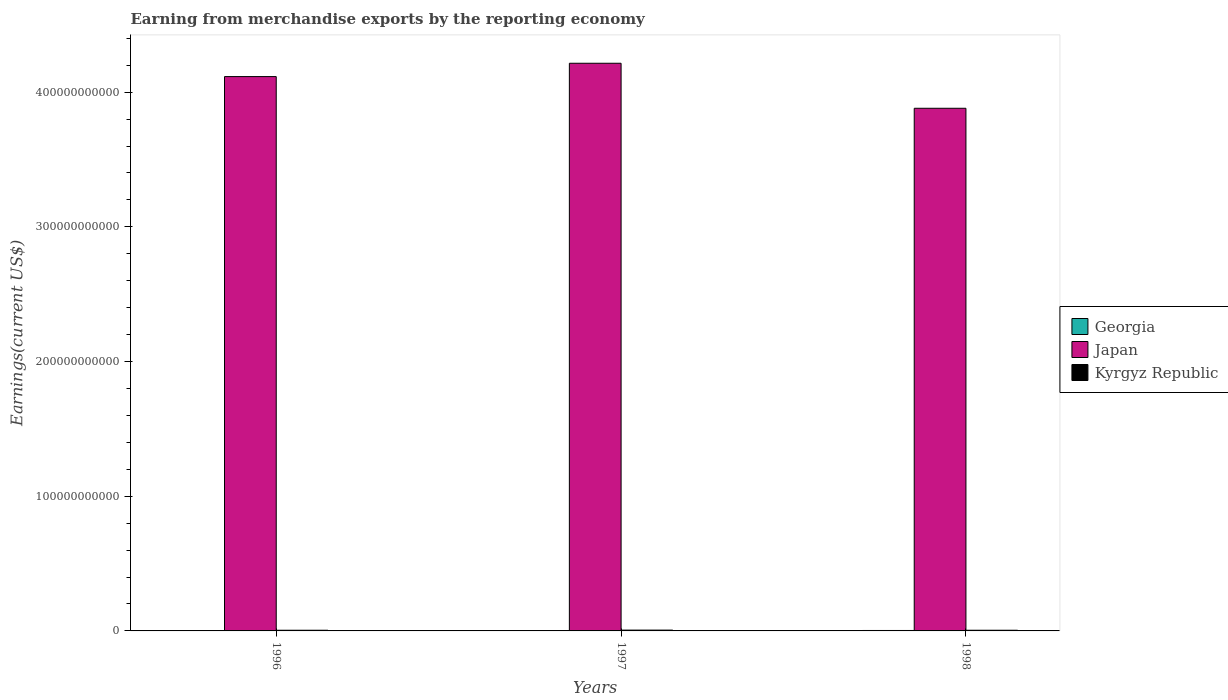Are the number of bars per tick equal to the number of legend labels?
Keep it short and to the point. Yes. Are the number of bars on each tick of the X-axis equal?
Keep it short and to the point. Yes. How many bars are there on the 3rd tick from the right?
Your answer should be very brief. 3. What is the amount earned from merchandise exports in Japan in 1998?
Provide a short and direct response. 3.88e+11. Across all years, what is the maximum amount earned from merchandise exports in Georgia?
Make the answer very short. 3.31e+08. Across all years, what is the minimum amount earned from merchandise exports in Japan?
Give a very brief answer. 3.88e+11. In which year was the amount earned from merchandise exports in Kyrgyz Republic maximum?
Your answer should be compact. 1997. In which year was the amount earned from merchandise exports in Georgia minimum?
Provide a short and direct response. 1996. What is the total amount earned from merchandise exports in Japan in the graph?
Your response must be concise. 1.22e+12. What is the difference between the amount earned from merchandise exports in Kyrgyz Republic in 1997 and that in 1998?
Keep it short and to the point. 1.01e+08. What is the difference between the amount earned from merchandise exports in Kyrgyz Republic in 1998 and the amount earned from merchandise exports in Japan in 1997?
Your answer should be compact. -4.21e+11. What is the average amount earned from merchandise exports in Kyrgyz Republic per year?
Ensure brevity in your answer.  5.41e+08. In the year 1998, what is the difference between the amount earned from merchandise exports in Georgia and amount earned from merchandise exports in Kyrgyz Republic?
Make the answer very short. -1.78e+08. In how many years, is the amount earned from merchandise exports in Georgia greater than 140000000000 US$?
Offer a terse response. 0. What is the ratio of the amount earned from merchandise exports in Japan in 1996 to that in 1997?
Your answer should be very brief. 0.98. Is the difference between the amount earned from merchandise exports in Georgia in 1997 and 1998 greater than the difference between the amount earned from merchandise exports in Kyrgyz Republic in 1997 and 1998?
Make the answer very short. No. What is the difference between the highest and the second highest amount earned from merchandise exports in Georgia?
Make the answer very short. 1.01e+08. What is the difference between the highest and the lowest amount earned from merchandise exports in Kyrgyz Republic?
Your answer should be compact. 1.04e+08. Is the sum of the amount earned from merchandise exports in Japan in 1997 and 1998 greater than the maximum amount earned from merchandise exports in Kyrgyz Republic across all years?
Offer a very short reply. Yes. What does the 3rd bar from the left in 1997 represents?
Offer a terse response. Kyrgyz Republic. Is it the case that in every year, the sum of the amount earned from merchandise exports in Japan and amount earned from merchandise exports in Georgia is greater than the amount earned from merchandise exports in Kyrgyz Republic?
Your answer should be very brief. Yes. What is the difference between two consecutive major ticks on the Y-axis?
Your answer should be very brief. 1.00e+11. Where does the legend appear in the graph?
Give a very brief answer. Center right. How many legend labels are there?
Your answer should be compact. 3. What is the title of the graph?
Your answer should be very brief. Earning from merchandise exports by the reporting economy. What is the label or title of the X-axis?
Your answer should be very brief. Years. What is the label or title of the Y-axis?
Provide a short and direct response. Earnings(current US$). What is the Earnings(current US$) of Georgia in 1996?
Make the answer very short. 1.99e+08. What is the Earnings(current US$) of Japan in 1996?
Your response must be concise. 4.12e+11. What is the Earnings(current US$) of Kyrgyz Republic in 1996?
Give a very brief answer. 5.06e+08. What is the Earnings(current US$) of Georgia in 1997?
Provide a short and direct response. 2.30e+08. What is the Earnings(current US$) in Japan in 1997?
Provide a succinct answer. 4.21e+11. What is the Earnings(current US$) in Kyrgyz Republic in 1997?
Provide a short and direct response. 6.09e+08. What is the Earnings(current US$) in Georgia in 1998?
Offer a very short reply. 3.31e+08. What is the Earnings(current US$) of Japan in 1998?
Offer a very short reply. 3.88e+11. What is the Earnings(current US$) in Kyrgyz Republic in 1998?
Provide a short and direct response. 5.09e+08. Across all years, what is the maximum Earnings(current US$) in Georgia?
Provide a short and direct response. 3.31e+08. Across all years, what is the maximum Earnings(current US$) in Japan?
Ensure brevity in your answer.  4.21e+11. Across all years, what is the maximum Earnings(current US$) of Kyrgyz Republic?
Your answer should be compact. 6.09e+08. Across all years, what is the minimum Earnings(current US$) in Georgia?
Your response must be concise. 1.99e+08. Across all years, what is the minimum Earnings(current US$) in Japan?
Your response must be concise. 3.88e+11. Across all years, what is the minimum Earnings(current US$) of Kyrgyz Republic?
Keep it short and to the point. 5.06e+08. What is the total Earnings(current US$) of Georgia in the graph?
Keep it short and to the point. 7.60e+08. What is the total Earnings(current US$) of Japan in the graph?
Give a very brief answer. 1.22e+12. What is the total Earnings(current US$) in Kyrgyz Republic in the graph?
Your answer should be very brief. 1.62e+09. What is the difference between the Earnings(current US$) in Georgia in 1996 and that in 1997?
Provide a succinct answer. -3.13e+07. What is the difference between the Earnings(current US$) of Japan in 1996 and that in 1997?
Provide a short and direct response. -9.89e+09. What is the difference between the Earnings(current US$) in Kyrgyz Republic in 1996 and that in 1997?
Offer a terse response. -1.04e+08. What is the difference between the Earnings(current US$) of Georgia in 1996 and that in 1998?
Your answer should be compact. -1.32e+08. What is the difference between the Earnings(current US$) in Japan in 1996 and that in 1998?
Provide a short and direct response. 2.35e+1. What is the difference between the Earnings(current US$) in Kyrgyz Republic in 1996 and that in 1998?
Ensure brevity in your answer.  -2.91e+06. What is the difference between the Earnings(current US$) in Georgia in 1997 and that in 1998?
Your answer should be compact. -1.01e+08. What is the difference between the Earnings(current US$) in Japan in 1997 and that in 1998?
Your response must be concise. 3.34e+1. What is the difference between the Earnings(current US$) of Kyrgyz Republic in 1997 and that in 1998?
Provide a succinct answer. 1.01e+08. What is the difference between the Earnings(current US$) of Georgia in 1996 and the Earnings(current US$) of Japan in 1997?
Your response must be concise. -4.21e+11. What is the difference between the Earnings(current US$) of Georgia in 1996 and the Earnings(current US$) of Kyrgyz Republic in 1997?
Provide a short and direct response. -4.11e+08. What is the difference between the Earnings(current US$) of Japan in 1996 and the Earnings(current US$) of Kyrgyz Republic in 1997?
Ensure brevity in your answer.  4.11e+11. What is the difference between the Earnings(current US$) of Georgia in 1996 and the Earnings(current US$) of Japan in 1998?
Ensure brevity in your answer.  -3.88e+11. What is the difference between the Earnings(current US$) of Georgia in 1996 and the Earnings(current US$) of Kyrgyz Republic in 1998?
Provide a succinct answer. -3.10e+08. What is the difference between the Earnings(current US$) of Japan in 1996 and the Earnings(current US$) of Kyrgyz Republic in 1998?
Offer a very short reply. 4.11e+11. What is the difference between the Earnings(current US$) in Georgia in 1997 and the Earnings(current US$) in Japan in 1998?
Offer a terse response. -3.88e+11. What is the difference between the Earnings(current US$) of Georgia in 1997 and the Earnings(current US$) of Kyrgyz Republic in 1998?
Make the answer very short. -2.79e+08. What is the difference between the Earnings(current US$) of Japan in 1997 and the Earnings(current US$) of Kyrgyz Republic in 1998?
Give a very brief answer. 4.21e+11. What is the average Earnings(current US$) in Georgia per year?
Keep it short and to the point. 2.53e+08. What is the average Earnings(current US$) of Japan per year?
Offer a very short reply. 4.07e+11. What is the average Earnings(current US$) in Kyrgyz Republic per year?
Your response must be concise. 5.41e+08. In the year 1996, what is the difference between the Earnings(current US$) in Georgia and Earnings(current US$) in Japan?
Keep it short and to the point. -4.11e+11. In the year 1996, what is the difference between the Earnings(current US$) in Georgia and Earnings(current US$) in Kyrgyz Republic?
Keep it short and to the point. -3.07e+08. In the year 1996, what is the difference between the Earnings(current US$) of Japan and Earnings(current US$) of Kyrgyz Republic?
Offer a very short reply. 4.11e+11. In the year 1997, what is the difference between the Earnings(current US$) in Georgia and Earnings(current US$) in Japan?
Provide a short and direct response. -4.21e+11. In the year 1997, what is the difference between the Earnings(current US$) of Georgia and Earnings(current US$) of Kyrgyz Republic?
Ensure brevity in your answer.  -3.79e+08. In the year 1997, what is the difference between the Earnings(current US$) in Japan and Earnings(current US$) in Kyrgyz Republic?
Your answer should be very brief. 4.21e+11. In the year 1998, what is the difference between the Earnings(current US$) of Georgia and Earnings(current US$) of Japan?
Offer a very short reply. -3.88e+11. In the year 1998, what is the difference between the Earnings(current US$) in Georgia and Earnings(current US$) in Kyrgyz Republic?
Your answer should be very brief. -1.78e+08. In the year 1998, what is the difference between the Earnings(current US$) in Japan and Earnings(current US$) in Kyrgyz Republic?
Provide a short and direct response. 3.88e+11. What is the ratio of the Earnings(current US$) of Georgia in 1996 to that in 1997?
Your response must be concise. 0.86. What is the ratio of the Earnings(current US$) of Japan in 1996 to that in 1997?
Your answer should be very brief. 0.98. What is the ratio of the Earnings(current US$) of Kyrgyz Republic in 1996 to that in 1997?
Your answer should be compact. 0.83. What is the ratio of the Earnings(current US$) in Georgia in 1996 to that in 1998?
Your answer should be compact. 0.6. What is the ratio of the Earnings(current US$) in Japan in 1996 to that in 1998?
Give a very brief answer. 1.06. What is the ratio of the Earnings(current US$) of Kyrgyz Republic in 1996 to that in 1998?
Make the answer very short. 0.99. What is the ratio of the Earnings(current US$) in Georgia in 1997 to that in 1998?
Provide a succinct answer. 0.7. What is the ratio of the Earnings(current US$) in Japan in 1997 to that in 1998?
Provide a succinct answer. 1.09. What is the ratio of the Earnings(current US$) in Kyrgyz Republic in 1997 to that in 1998?
Your answer should be compact. 1.2. What is the difference between the highest and the second highest Earnings(current US$) of Georgia?
Offer a very short reply. 1.01e+08. What is the difference between the highest and the second highest Earnings(current US$) in Japan?
Give a very brief answer. 9.89e+09. What is the difference between the highest and the second highest Earnings(current US$) in Kyrgyz Republic?
Provide a short and direct response. 1.01e+08. What is the difference between the highest and the lowest Earnings(current US$) of Georgia?
Ensure brevity in your answer.  1.32e+08. What is the difference between the highest and the lowest Earnings(current US$) of Japan?
Provide a succinct answer. 3.34e+1. What is the difference between the highest and the lowest Earnings(current US$) in Kyrgyz Republic?
Provide a succinct answer. 1.04e+08. 